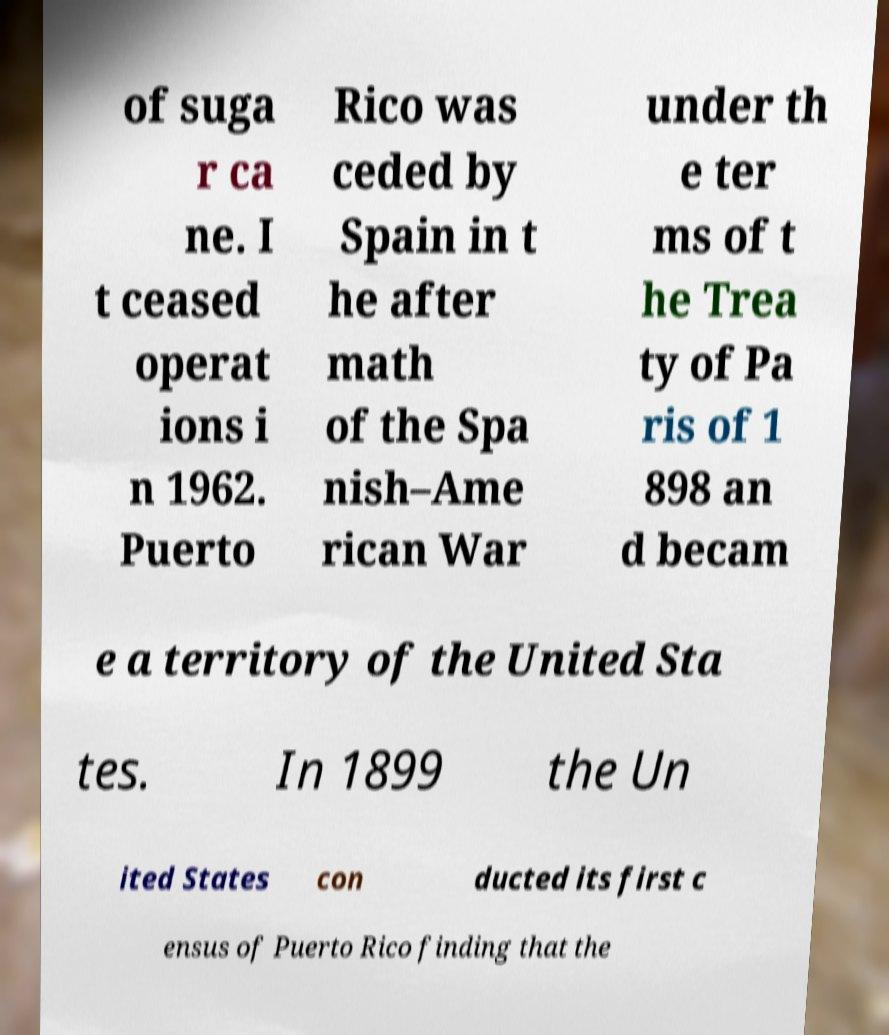Can you accurately transcribe the text from the provided image for me? of suga r ca ne. I t ceased operat ions i n 1962. Puerto Rico was ceded by Spain in t he after math of the Spa nish–Ame rican War under th e ter ms of t he Trea ty of Pa ris of 1 898 an d becam e a territory of the United Sta tes. In 1899 the Un ited States con ducted its first c ensus of Puerto Rico finding that the 